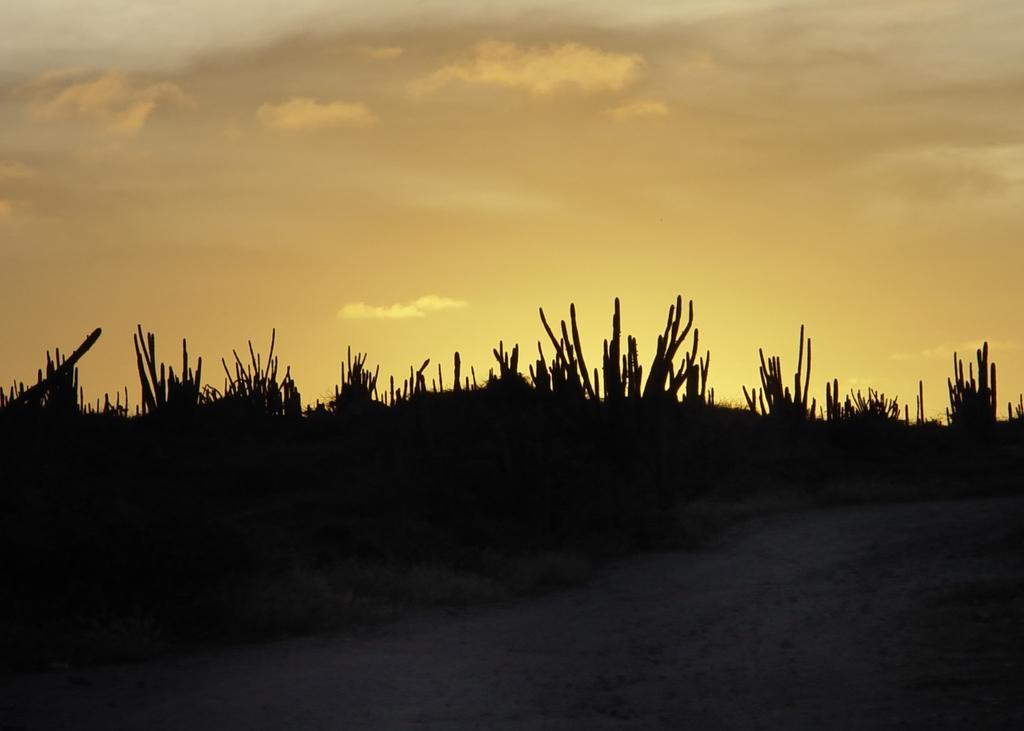Describe this image in one or two sentences. In this image in the center there are some plants, and at the bottom there is a walkway and at the top of the image there is sky. 